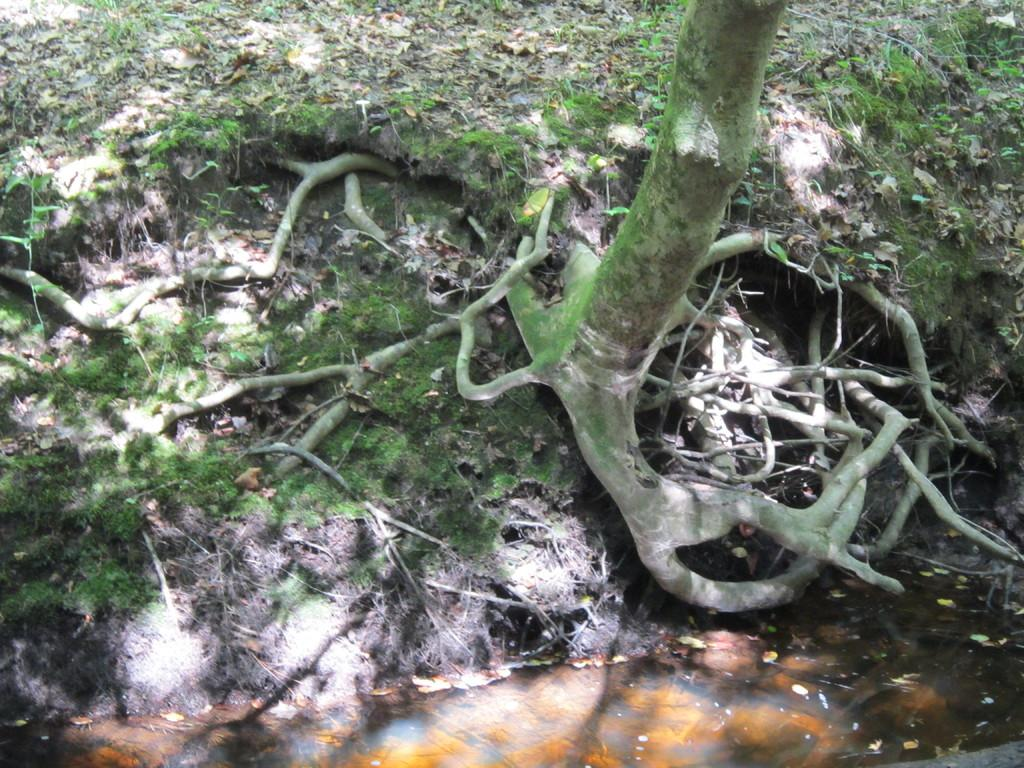What part of the tree can be seen on the ground in the image? The tree's roots are visible on the ground in the image. What is present at the bottom of the image? There is water at the bottom of the image. What can be seen at the top of the image? Leaves are present at the top of the image, and grass is also visible there. How many secretaries are sitting on the boats in the image? There are no secretaries or boats present in the image. 